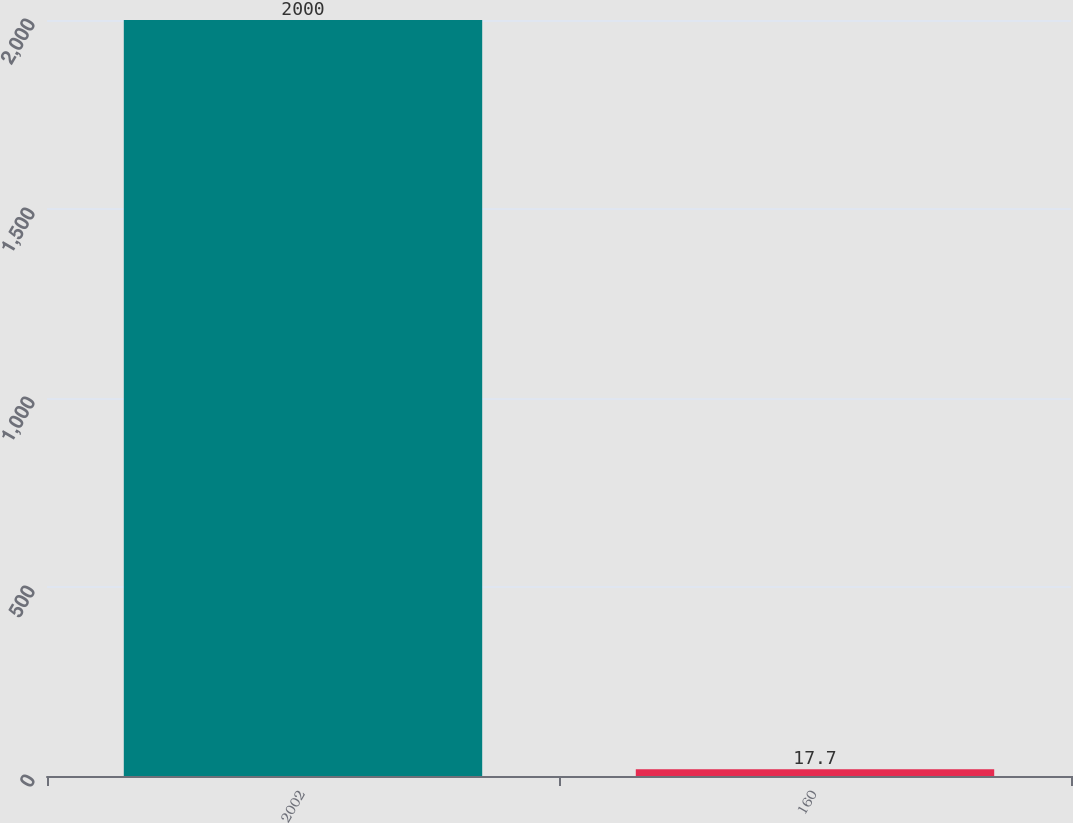<chart> <loc_0><loc_0><loc_500><loc_500><bar_chart><fcel>2002<fcel>160<nl><fcel>2000<fcel>17.7<nl></chart> 